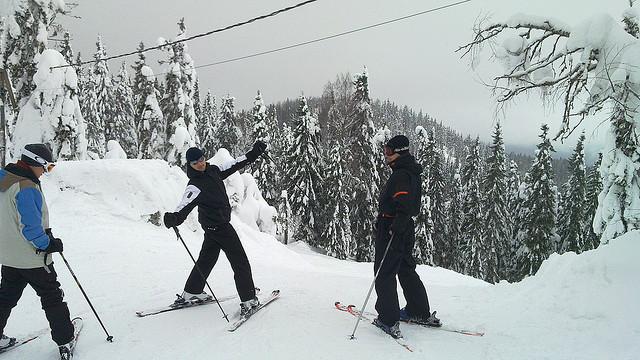Are there power lines in this photo?
Quick response, please. Yes. What color are the sleeves of the man on the left?
Short answer required. Blue. How many guys are skiing?
Answer briefly. 3. Are skier facing the same direction?
Concise answer only. No. 